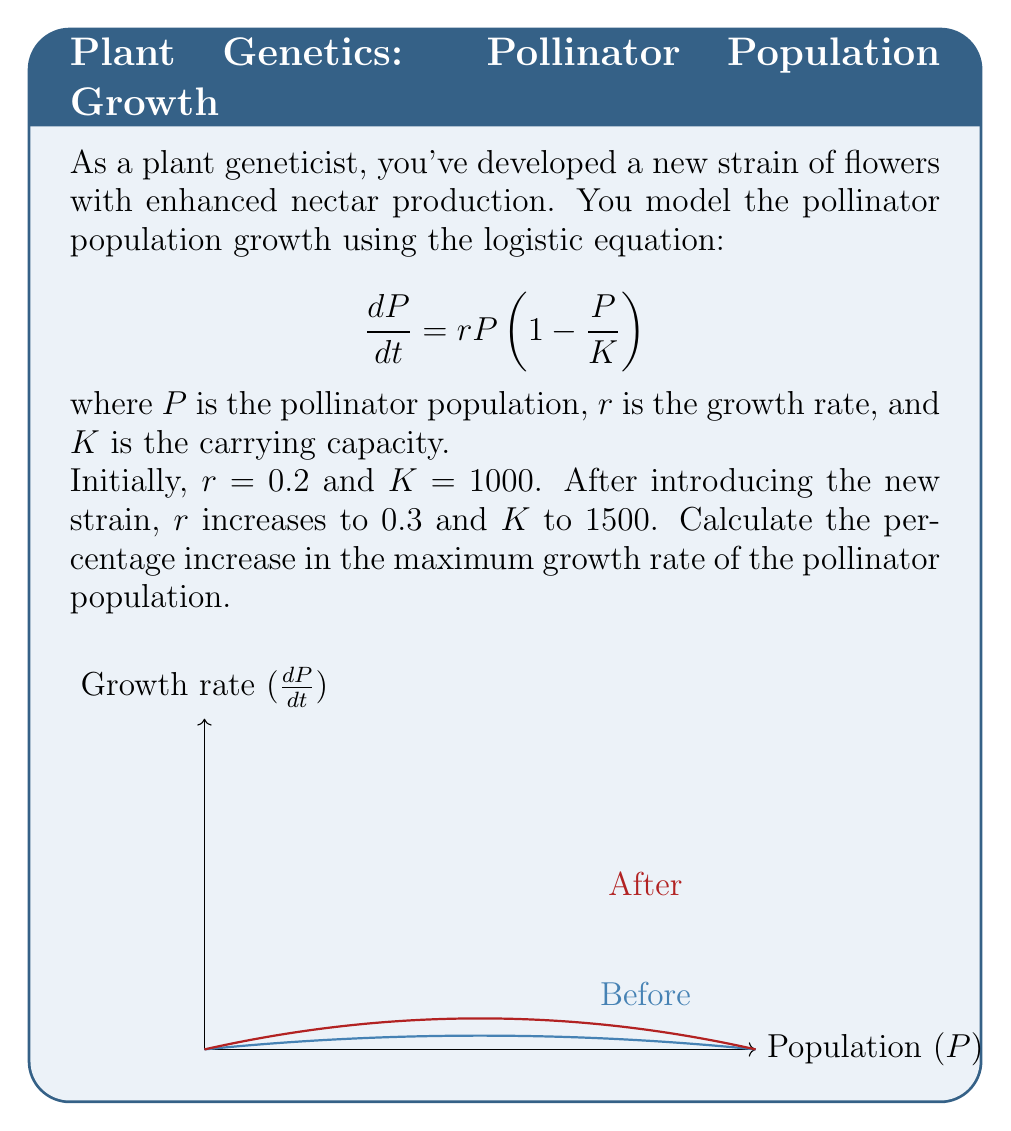Show me your answer to this math problem. Let's approach this step-by-step:

1) The maximum growth rate occurs at the peak of the logistic growth curve. To find this, we need to determine the population size at which $\frac{dP}{dt}$ is maximum.

2) Differentiate $\frac{dP}{dt}$ with respect to $P$:

   $$\frac{d}{dP}(\frac{dP}{dt}) = r - \frac{2rP}{K}$$

3) Set this equal to zero and solve for $P$:

   $$r - \frac{2rP}{K} = 0$$
   $$P = \frac{K}{2}$$

4) This shows that the maximum growth rate occurs when the population is half the carrying capacity.

5) Substitute $P = \frac{K}{2}$ into the original equation to find the maximum growth rate:

   $$(\frac{dP}{dt})_{max} = r\frac{K}{2}(1 - \frac{K/2}{K}) = r\frac{K}{2} \cdot \frac{1}{2} = \frac{rK}{4}$$

6) Before the new strain:
   $$(\frac{dP}{dt})_{max,before} = \frac{0.2 \cdot 1000}{4} = 50$$

7) After the new strain:
   $$(\frac{dP}{dt})_{max,after} = \frac{0.3 \cdot 1500}{4} = 112.5$$

8) Calculate the percentage increase:

   $$\text{Percentage increase} = \frac{112.5 - 50}{50} \cdot 100\% = 125\%$$
Answer: 125% 